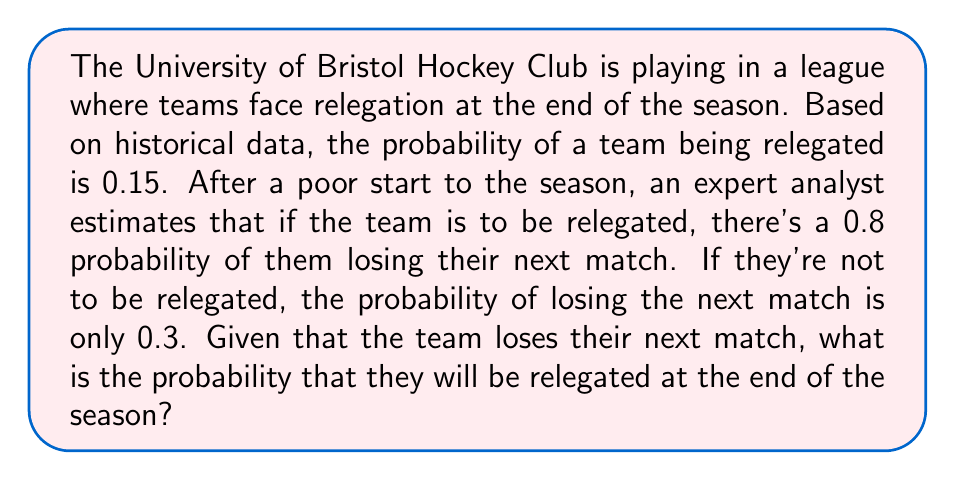Solve this math problem. Let's approach this problem using Bayesian inference:

1) Define our events:
   R: The team is relegated
   L: The team loses the next match

2) Given information:
   P(R) = 0.15 (prior probability of relegation)
   P(L|R) = 0.8 (probability of losing given relegation)
   P(L|not R) = 0.3 (probability of losing given no relegation)

3) We need to find P(R|L) using Bayes' theorem:

   $$P(R|L) = \frac{P(L|R) \cdot P(R)}{P(L)}$$

4) We know P(L|R) and P(R), but we need to calculate P(L):

   $$P(L) = P(L|R) \cdot P(R) + P(L|not R) \cdot P(not R)$$

5) Calculate P(not R):
   P(not R) = 1 - P(R) = 1 - 0.15 = 0.85

6) Now we can calculate P(L):
   $$P(L) = 0.8 \cdot 0.15 + 0.3 \cdot 0.85 = 0.12 + 0.255 = 0.375$$

7) Finally, we can use Bayes' theorem:

   $$P(R|L) = \frac{0.8 \cdot 0.15}{0.375} = \frac{0.12}{0.375} = 0.32$$

Therefore, given that the team loses their next match, the probability of relegation is 0.32 or 32%.
Answer: 0.32 